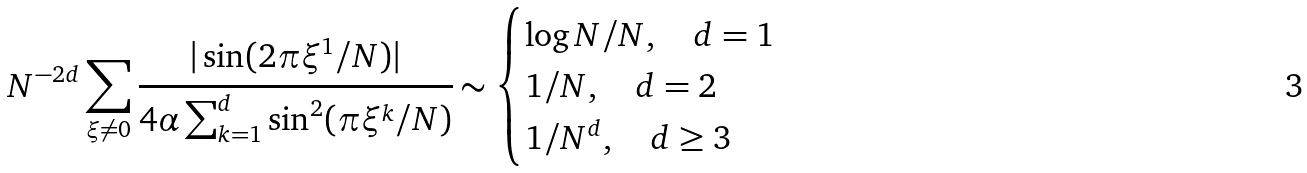Convert formula to latex. <formula><loc_0><loc_0><loc_500><loc_500>N ^ { - 2 d } \sum _ { \xi \neq 0 } \cfrac { | \sin ( 2 \pi \xi ^ { 1 } / N ) | } { 4 \alpha \sum _ { k = 1 } ^ { d } \sin ^ { 2 } ( \pi \xi ^ { k } / N ) } \sim \begin{cases} \log N / N , \quad d = 1 \\ 1 / N , \quad d = 2 \\ 1 / N ^ { d } , \quad d \geq 3 \end{cases}</formula> 